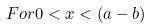Convert formula to latex. <formula><loc_0><loc_0><loc_500><loc_500>F o r 0 < x < ( a - b )</formula> 